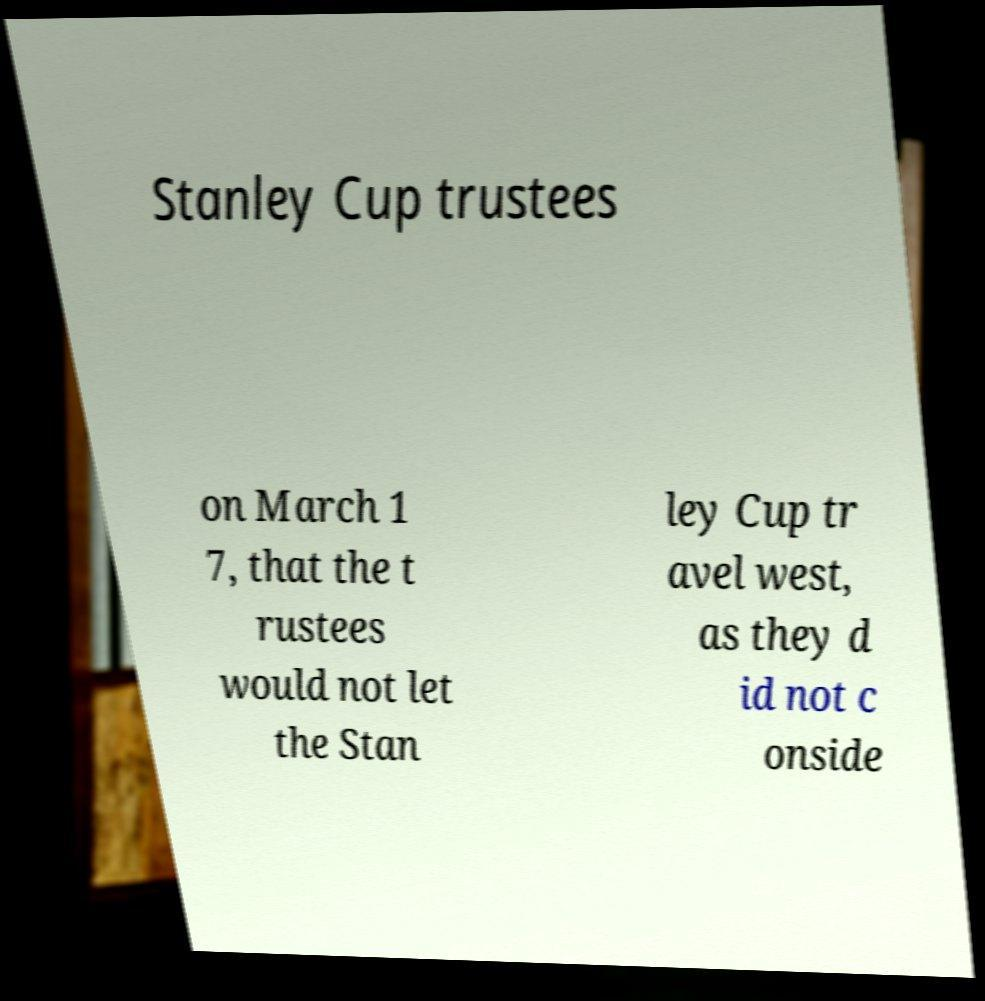Please identify and transcribe the text found in this image. Stanley Cup trustees on March 1 7, that the t rustees would not let the Stan ley Cup tr avel west, as they d id not c onside 